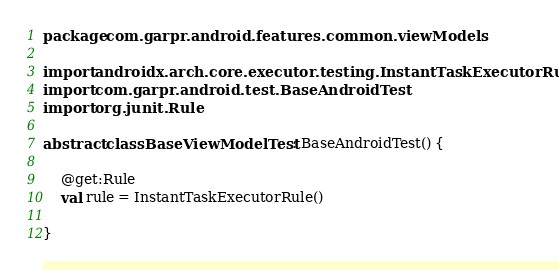Convert code to text. <code><loc_0><loc_0><loc_500><loc_500><_Kotlin_>package com.garpr.android.features.common.viewModels

import androidx.arch.core.executor.testing.InstantTaskExecutorRule
import com.garpr.android.test.BaseAndroidTest
import org.junit.Rule

abstract class BaseViewModelTest : BaseAndroidTest() {

    @get:Rule
    val rule = InstantTaskExecutorRule()

}
</code> 